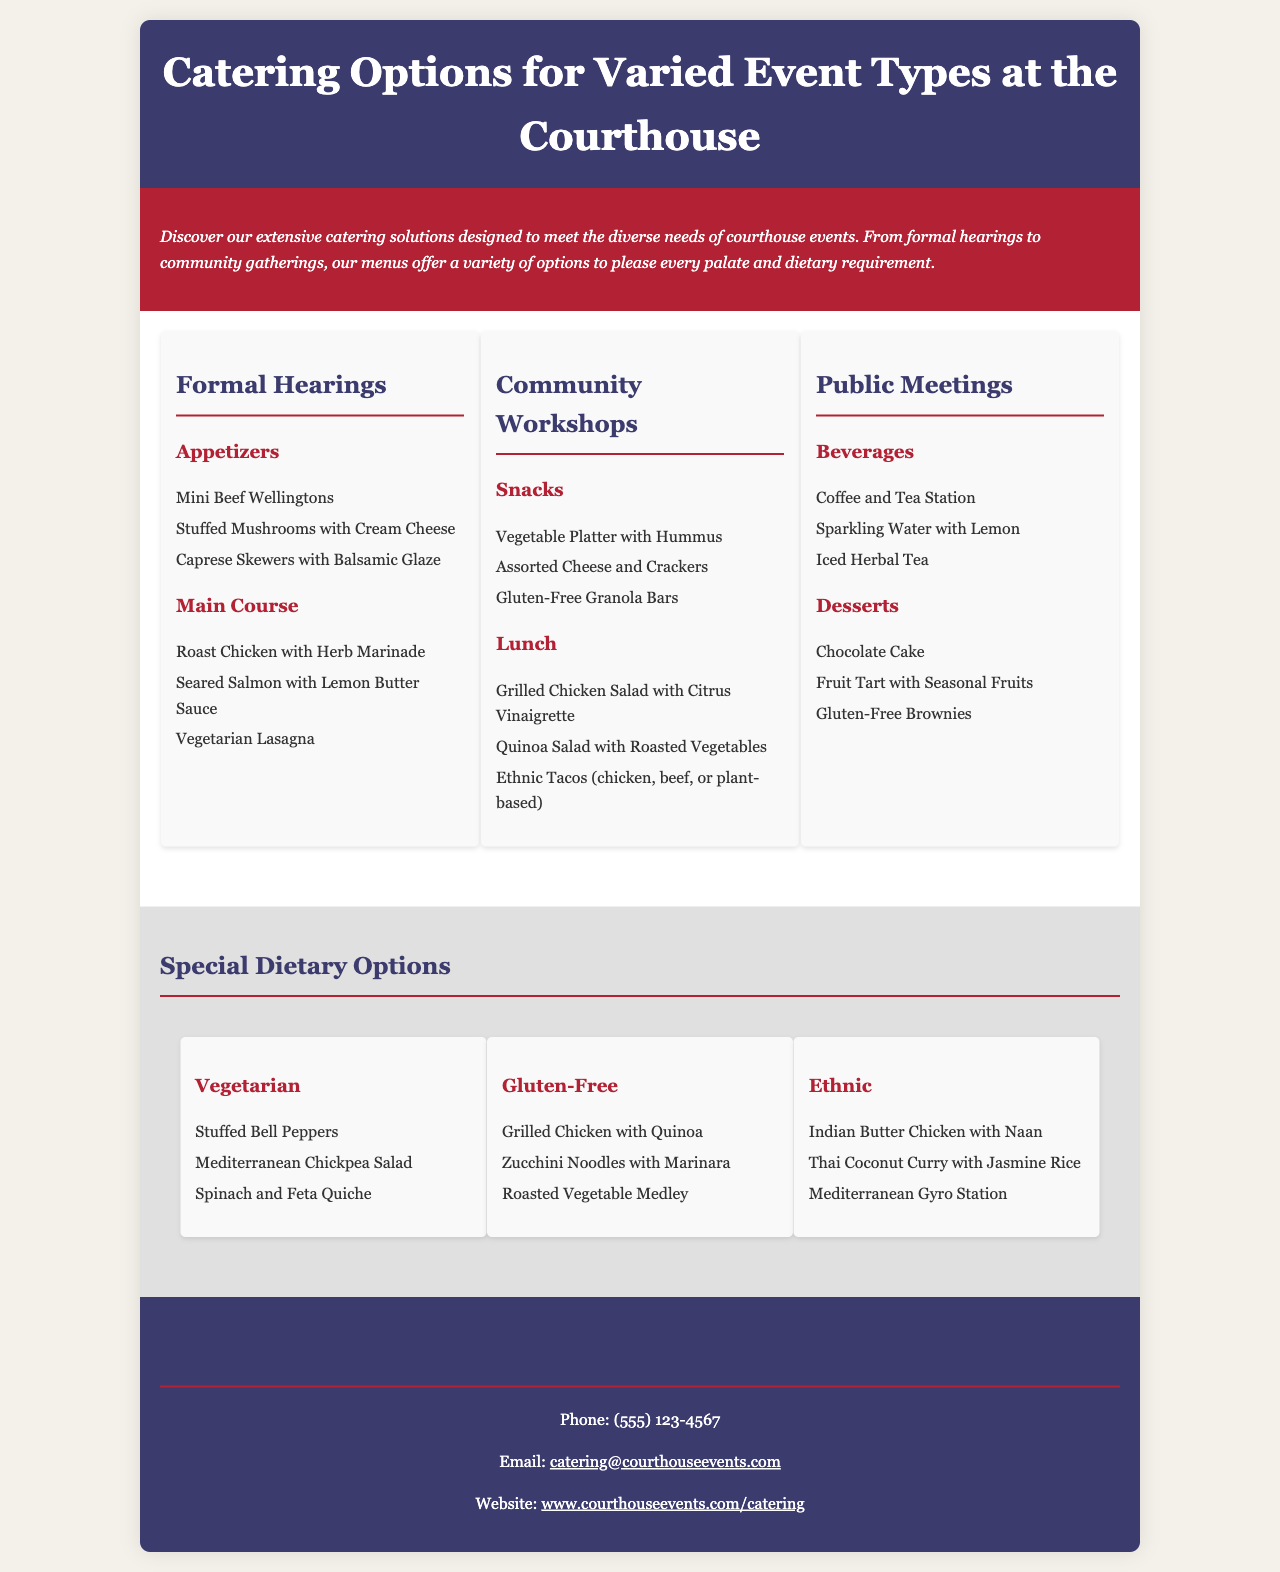What types of events does the brochure cover? The brochure showcases catering options tailored for formal hearings, community workshops, and public meetings.
Answer: Formal hearings, community workshops, public meetings What is one of the appetizers listed for formal hearings? The appetizers section for formal hearings includes Mini Beef Wellingtons.
Answer: Mini Beef Wellingtons What dietary options are highlighted in the brochure? The brochure provides information on vegetarian, gluten-free, and ethnic options available for catering.
Answer: Vegetarian, gluten-free, ethnic How many main courses are listed for formal hearings? There are three main courses mentioned for formal hearings: Roast Chicken, Seared Salmon, and Vegetarian Lasagna.
Answer: Three What is available in the snacks section for community workshops? The snacks section includes Vegetable Platter with Hummus, Assorted Cheese and Crackers, and Gluten-Free Granola Bars.
Answer: Vegetable Platter with Hummus, Assorted Cheese and Crackers, Gluten-Free Granola Bars Which special dietary option includes Stuffed Bell Peppers? The special dietary option that features Stuffed Bell Peppers is vegetarian.
Answer: Vegetarian What contact information is provided for inquiries? The contact information includes a phone number, email, and website for reaching out regarding catering options.
Answer: Phone: (555) 123-4567, Email: catering@courthouseevents.com, Website: www.courthouseevents.com/catering What beverage options are offered at public meetings? The beverages listed for public meetings include Coffee, Tea, Sparkling Water, and Iced Herbal Tea.
Answer: Coffee and Tea Station, Sparkling Water with Lemon, Iced Herbal Tea 